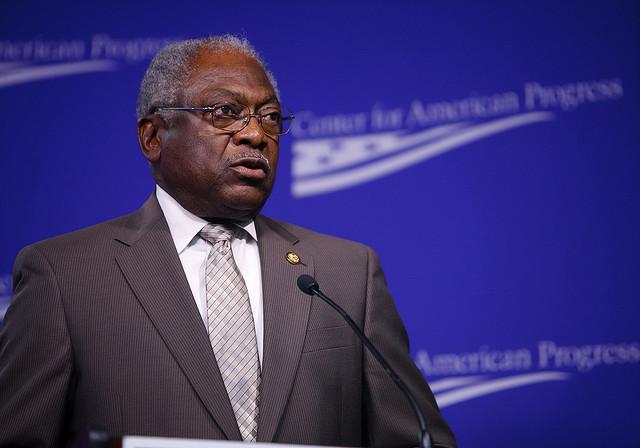What color is the man's hair?
Give a very brief answer. Gray. Is this an elderly man?
Write a very short answer. Yes. Does he have a mustache?
Short answer required. Yes. 